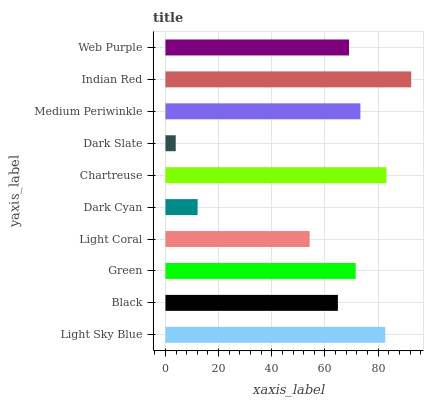Is Dark Slate the minimum?
Answer yes or no. Yes. Is Indian Red the maximum?
Answer yes or no. Yes. Is Black the minimum?
Answer yes or no. No. Is Black the maximum?
Answer yes or no. No. Is Light Sky Blue greater than Black?
Answer yes or no. Yes. Is Black less than Light Sky Blue?
Answer yes or no. Yes. Is Black greater than Light Sky Blue?
Answer yes or no. No. Is Light Sky Blue less than Black?
Answer yes or no. No. Is Green the high median?
Answer yes or no. Yes. Is Web Purple the low median?
Answer yes or no. Yes. Is Black the high median?
Answer yes or no. No. Is Chartreuse the low median?
Answer yes or no. No. 